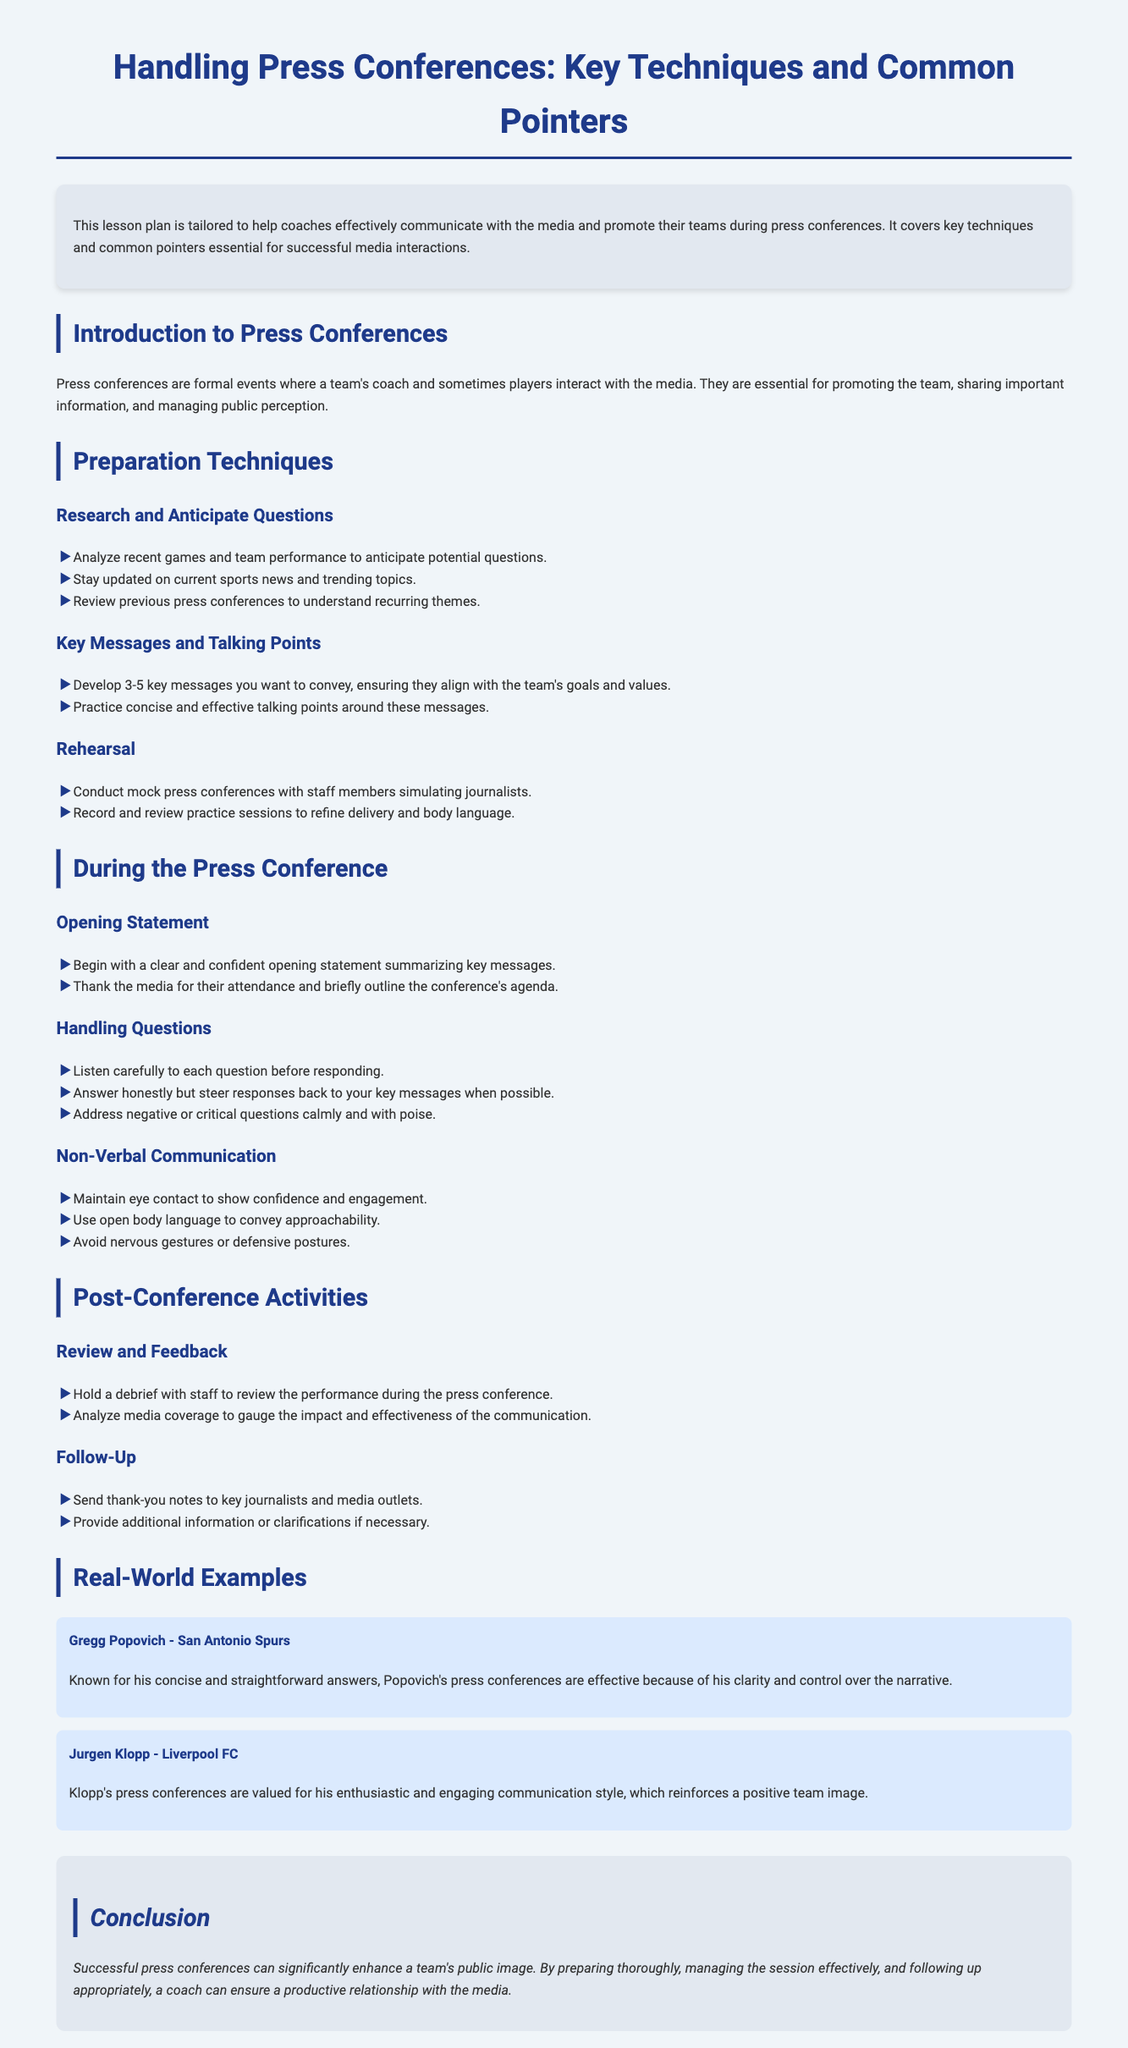What is the title of the lesson plan? The title is found at the beginning of the document, which states the main focus of the lesson.
Answer: Handling Press Conferences: Key Techniques and Common Pointers How many key messages should a coach develop? The document advises on the number of key messages to ensure effective communication.
Answer: 3-5 key messages What is the first technique mentioned under Preparation Techniques? The first technique listed pertains to preparing for potential press conference questions.
Answer: Research and Anticipate Questions What should a coach do after the press conference? The document outlines activities that occur post-conference, focusing on reviewing performance.
Answer: Review and Feedback Which coach is known for concise and straightforward answers? The document provides an example of a coach recognized for their effective communication style.
Answer: Gregg Popovich What is an essential aspect of handling questions during the press conference? The text emphasizes an important approach in responding to media inquiries.
Answer: Listen carefully to each question before responding What color is used for headings in the document? The document details the color scheme applied to headings, reflecting its design choices.
Answer: #1e3a8a What type of body language should be avoided during a press conference? The document highlights specific body language that may negatively impact communication.
Answer: Nervous gestures or defensive postures 